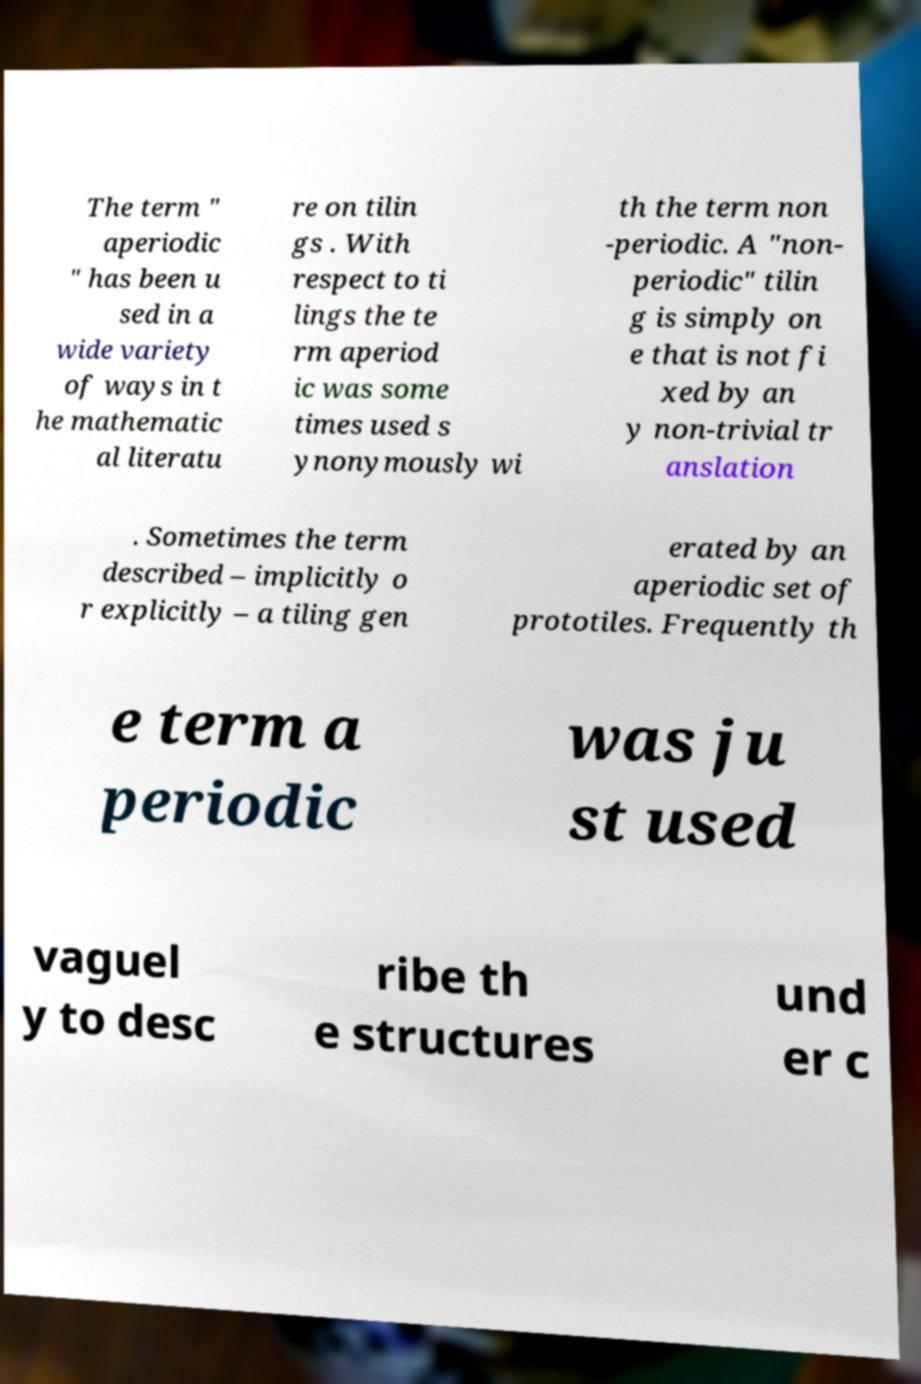Could you extract and type out the text from this image? The term " aperiodic " has been u sed in a wide variety of ways in t he mathematic al literatu re on tilin gs . With respect to ti lings the te rm aperiod ic was some times used s ynonymously wi th the term non -periodic. A "non- periodic" tilin g is simply on e that is not fi xed by an y non-trivial tr anslation . Sometimes the term described – implicitly o r explicitly – a tiling gen erated by an aperiodic set of prototiles. Frequently th e term a periodic was ju st used vaguel y to desc ribe th e structures und er c 